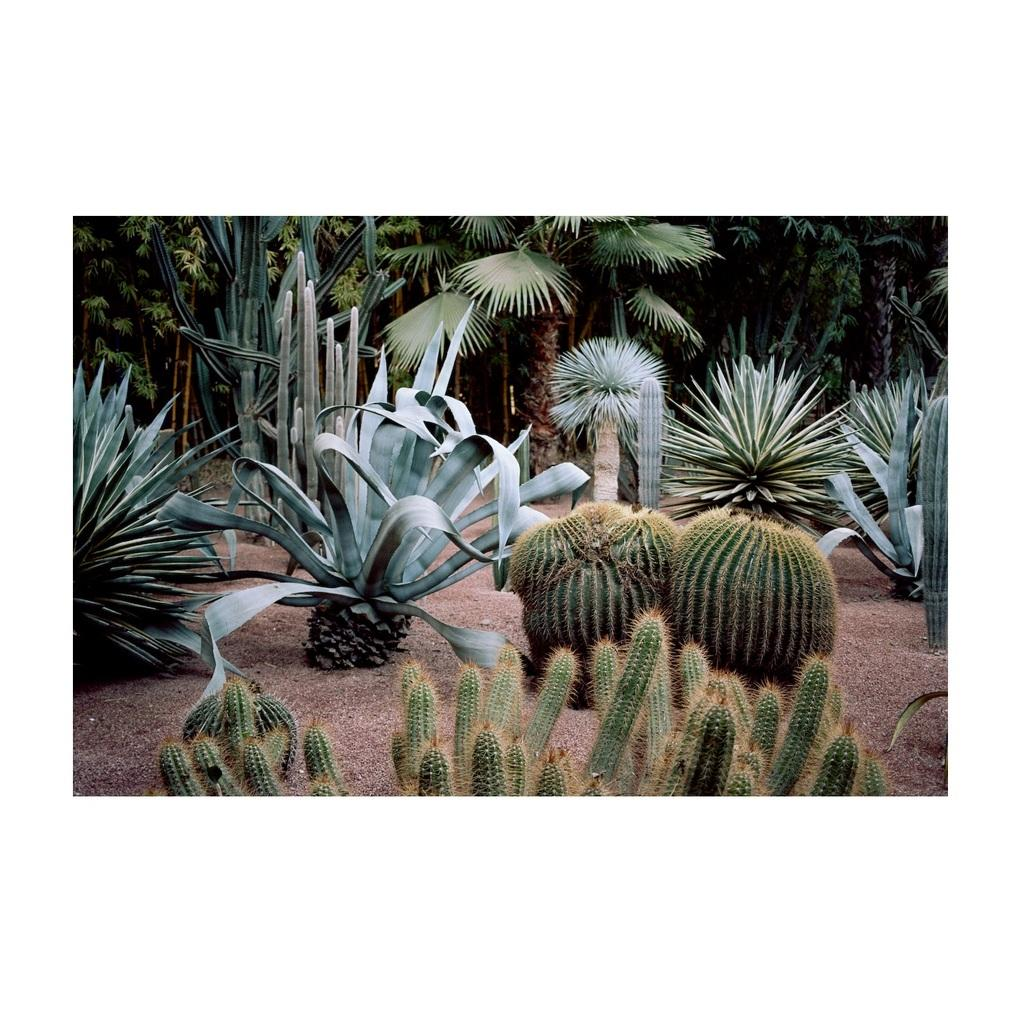What type of surface is visible in the image? The ground is visible in the image. What types of vegetation can be seen in the image? There are plants and trees in the image. What is the comparison between the plants and the waste in the image? There is no waste present in the image, so it is not possible to make a comparison between the plants and waste. 